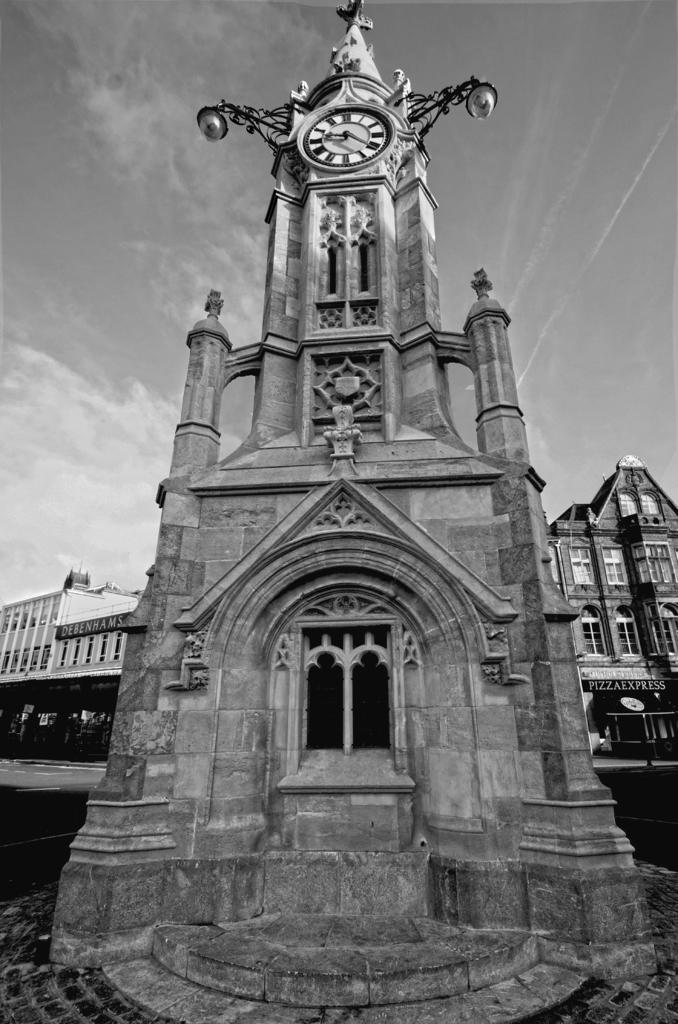What type of building is the main subject of the image? There is a church in the image. What feature can be seen on top of the church? The church has a wall clock on top of it. What can be seen in the background of the image? There are buildings and the sky visible in the background of the image. What type of holiday is being celebrated in the image? There is no indication of a holiday being celebrated in the image. Can you see a quiver of arrows in the image? There is no quiver of arrows present in the image. 